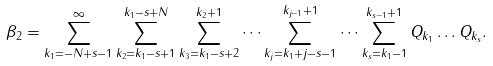<formula> <loc_0><loc_0><loc_500><loc_500>\beta _ { 2 } = \sum _ { k _ { 1 } = - N + s - 1 } ^ { \infty } \sum _ { k _ { 2 } = k _ { 1 } - s + 1 } ^ { k _ { 1 } - s + N } \sum _ { k _ { 3 } = k _ { 1 } - s + 2 } ^ { k _ { 2 } + 1 } \dots \sum _ { k _ { j } = k _ { 1 } + j - s - 1 } ^ { k _ { j - 1 } + 1 } \dots \sum _ { k _ { s } = k _ { 1 } - 1 } ^ { k _ { s - 1 } + 1 } Q _ { k _ { 1 } } \dots Q _ { k _ { s } } .</formula> 